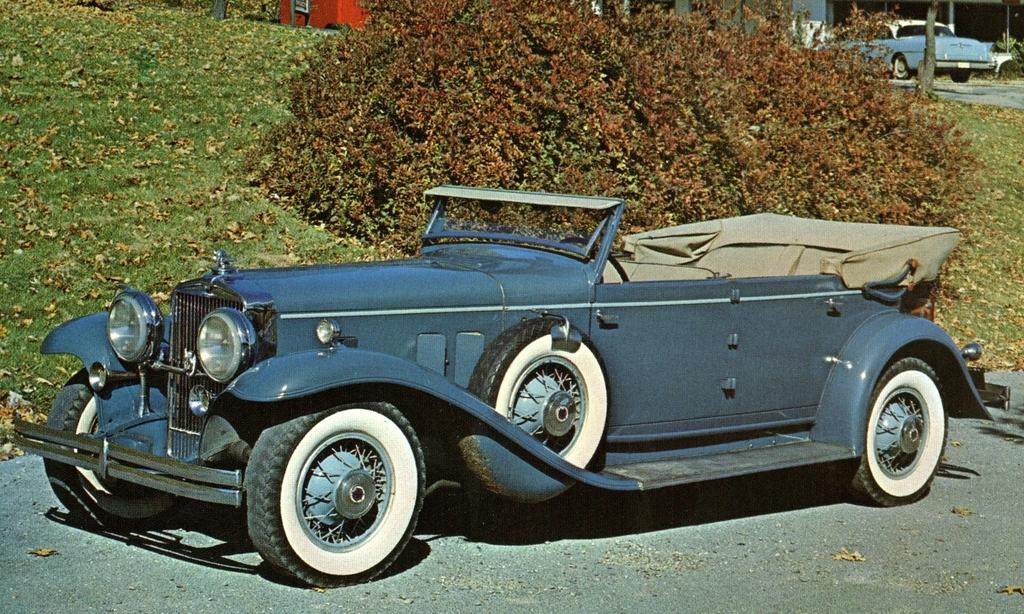What types of objects can be seen in the image? There are vehicles in the image. What natural elements are present in the image? There are trees, grass, and dried leaves in the image. What can be seen in the background of the image? There are buildings in the background of the image. What is visible at the bottom of the image? There is a road visible at the bottom of the image. What is the weight of the duck in the image? There is no duck present in the image, so its weight cannot be determined. How comfortable are the vehicles in the image? The comfort level of the vehicles cannot be determined from the image alone. 